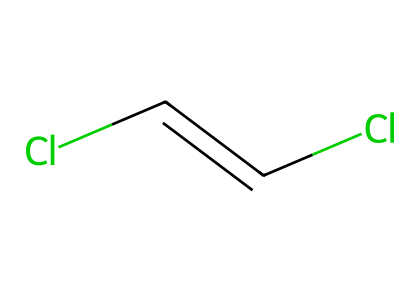How many chlorine atoms are present in 1,2-dichloroethene? The SMILES representation shows two "Cl" notations, indicating there are two chlorine atoms in the structure.
Answer: two What is the type of isomerism present in 1,2-dichloroethene? The presence of different spatial arrangements around the double bond (C=C) indicates that it exhibits geometric (cis-trans) isomerism.
Answer: geometric How many carbon atoms are in the structure of 1,2-dichloroethene? The SMILES representation contains two "C" notations, indicating there are two carbon atoms in the structure.
Answer: two Which geometric isomer is formed with the chlorine atoms on the same side? In 1,2-dichloroethene, the isomer with chlorine atoms on the same side of the double bond is called the cis isomer.
Answer: cis What effect might 1,2-dichloroethene contamination have on aquatic ecosystems? As a solvent and potential pollutant, 1,2-dichloroethene can be toxic to aquatic life, disrupting ecosystems and causing adverse health effects on wildlife.
Answer: toxic What distinguishes the cis isomer from the trans isomer in 1,2-dichloroethene? The cis isomer has both chlorine atoms on the same side of the double bond, whereas the trans isomer has them on opposite sides, leading to different physical properties.
Answer: positioning How many total bonds are present in the chemical structure of 1,2-dichloroethene? The structure contains one double bond between the two carbon atoms and two single bonds (one to each chlorine), totaling three bonds.
Answer: three 